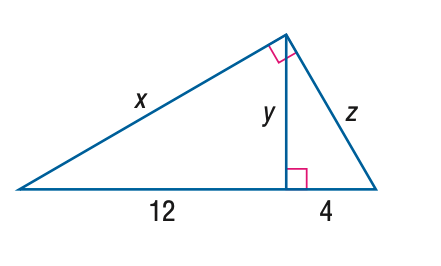Answer the mathemtical geometry problem and directly provide the correct option letter.
Question: Find z.
Choices: A: 4 \sqrt { 2 } B: 4 \sqrt { 3 } C: 8 D: 8 \sqrt { 3 } C 